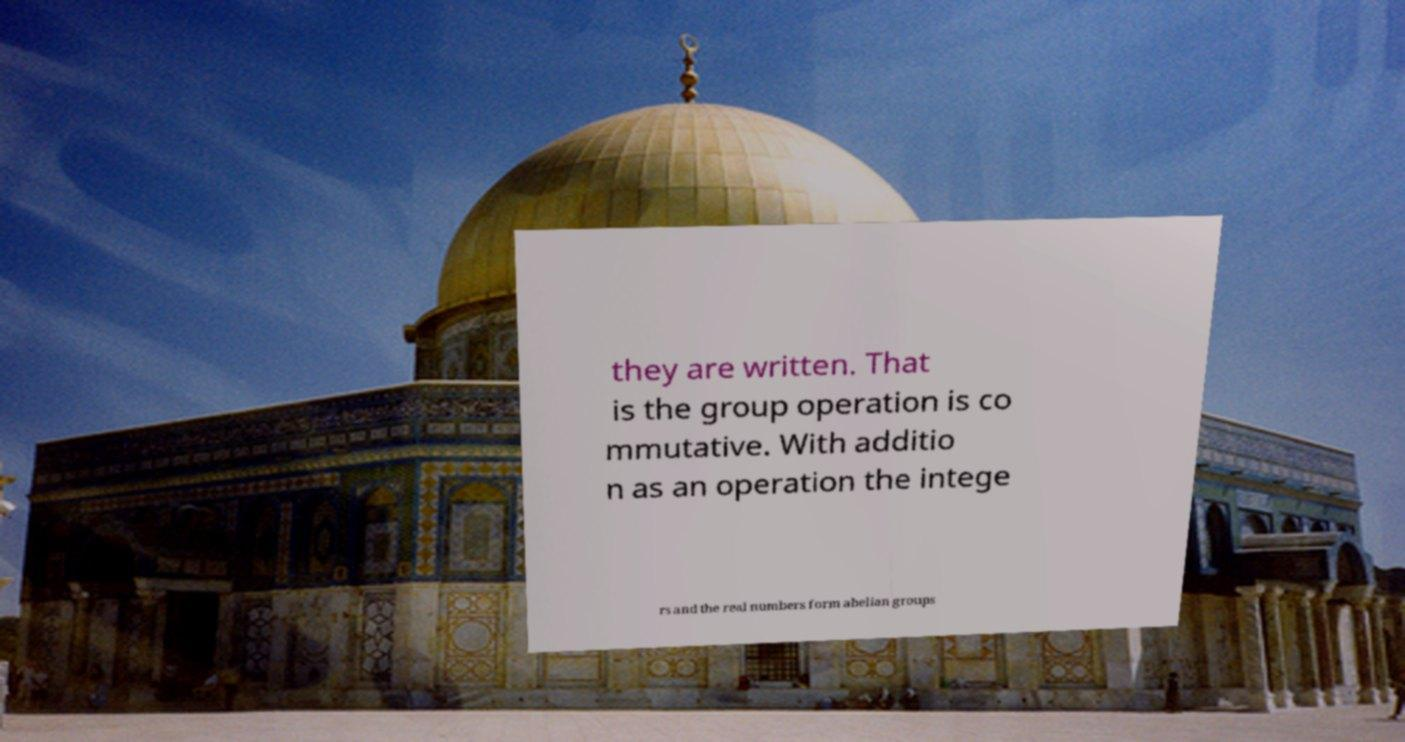Please read and relay the text visible in this image. What does it say? they are written. That is the group operation is co mmutative. With additio n as an operation the intege rs and the real numbers form abelian groups 